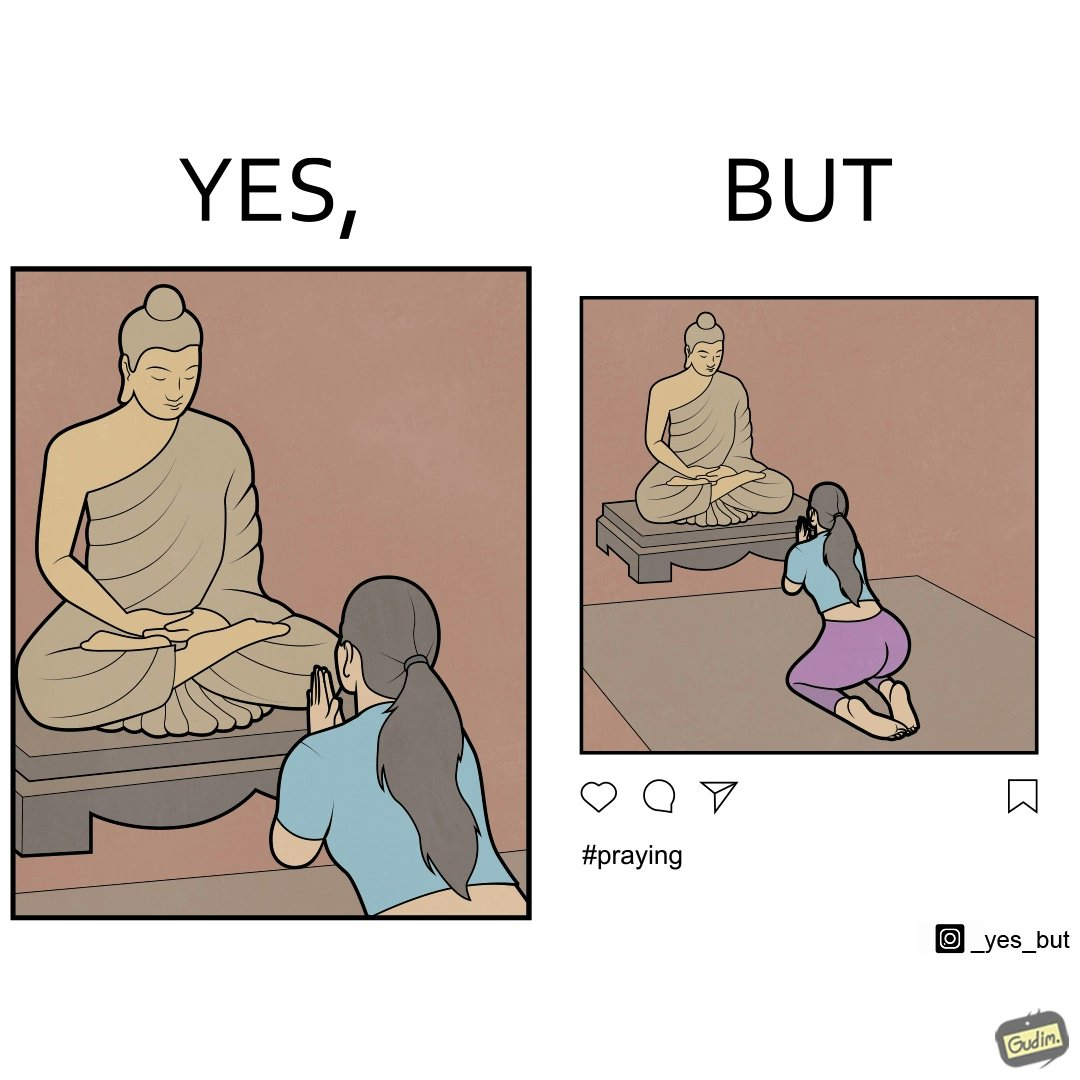Describe what you see in the left and right parts of this image. In the left part of the image: a woman is seen praying before the Buddha  statue with closed hands In the right part of the image: a photo of a woman, praying before the Buddha  statue with closed hands, posted on some social media  with hashtags 